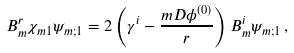<formula> <loc_0><loc_0><loc_500><loc_500>B ^ { r } _ { m } { \chi _ { m 1 } } \psi _ { m ; 1 } = 2 \left ( \gamma ^ { i } - \frac { m D { \phi } ^ { ( 0 ) } } { r } \right ) B ^ { i } _ { m } \psi _ { m ; 1 } \, ,</formula> 